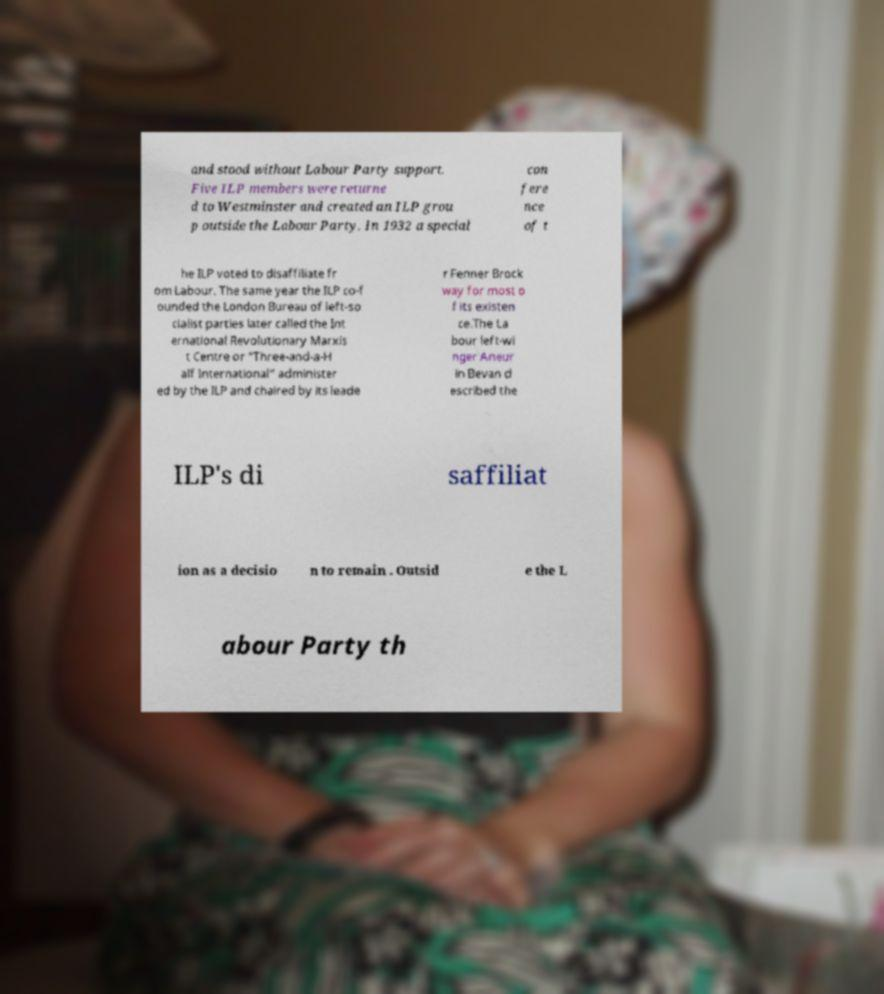Can you read and provide the text displayed in the image?This photo seems to have some interesting text. Can you extract and type it out for me? and stood without Labour Party support. Five ILP members were returne d to Westminster and created an ILP grou p outside the Labour Party. In 1932 a special con fere nce of t he ILP voted to disaffiliate fr om Labour. The same year the ILP co-f ounded the London Bureau of left-so cialist parties later called the Int ernational Revolutionary Marxis t Centre or "Three-and-a-H alf International" administer ed by the ILP and chaired by its leade r Fenner Brock way for most o f its existen ce.The La bour left-wi nger Aneur in Bevan d escribed the ILP's di saffiliat ion as a decisio n to remain . Outsid e the L abour Party th 